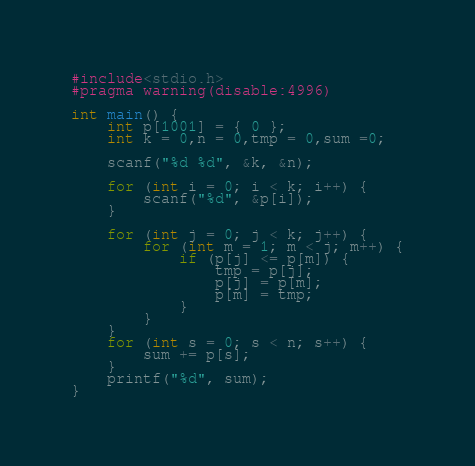<code> <loc_0><loc_0><loc_500><loc_500><_C_>#include<stdio.h>
#pragma warning(disable:4996)

int main() {
	int p[1001] = { 0 };
	int k = 0,n = 0,tmp = 0,sum =0;

	scanf("%d %d", &k, &n);

	for (int i = 0; i < k; i++) {
		scanf("%d", &p[i]);
	}

	for (int j = 0; j < k; j++) {
		for (int m = 1; m < j; m++) {
			if (p[j] <= p[m]) {
				tmp = p[j];
				p[j] = p[m];
				p[m] = tmp;
			}
		}
	}
	for (int s = 0; s < n; s++) {
		sum += p[s];
	}
	printf("%d", sum);
}</code> 